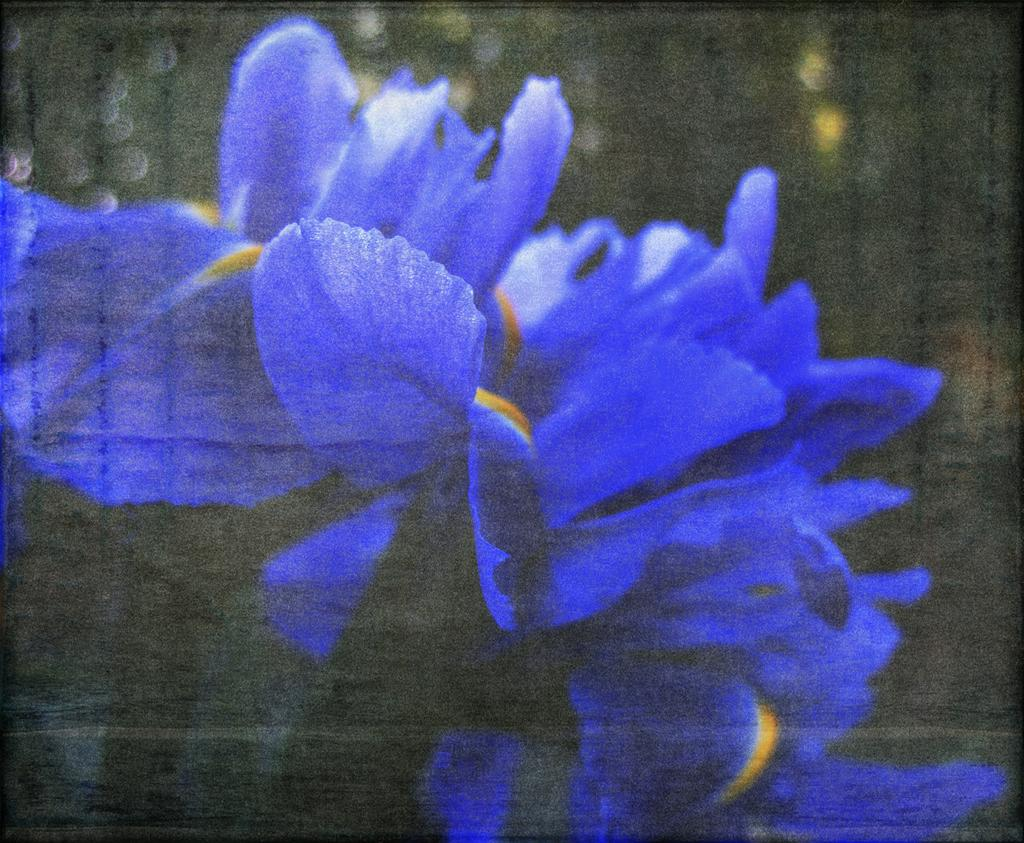What type of plants are in the picture? There are flowers in the picture. What color are the flowers? The flowers are blue in color. Can you describe the background of the image? The background of the image is blurry. What type of secretary can be seen working in the image? There is no secretary present in the image; it features blue flowers with a blurry background. 